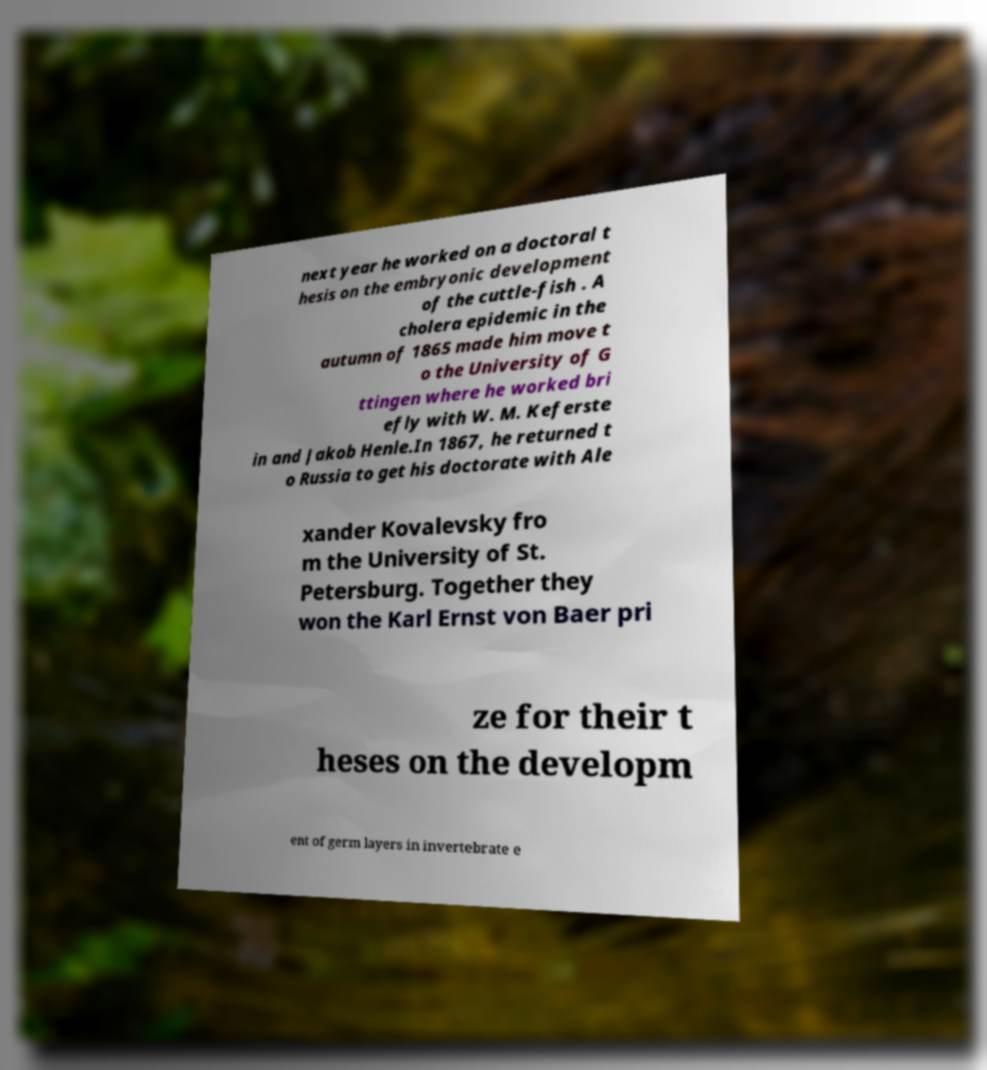Could you assist in decoding the text presented in this image and type it out clearly? next year he worked on a doctoral t hesis on the embryonic development of the cuttle-fish . A cholera epidemic in the autumn of 1865 made him move t o the University of G ttingen where he worked bri efly with W. M. Keferste in and Jakob Henle.In 1867, he returned t o Russia to get his doctorate with Ale xander Kovalevsky fro m the University of St. Petersburg. Together they won the Karl Ernst von Baer pri ze for their t heses on the developm ent of germ layers in invertebrate e 